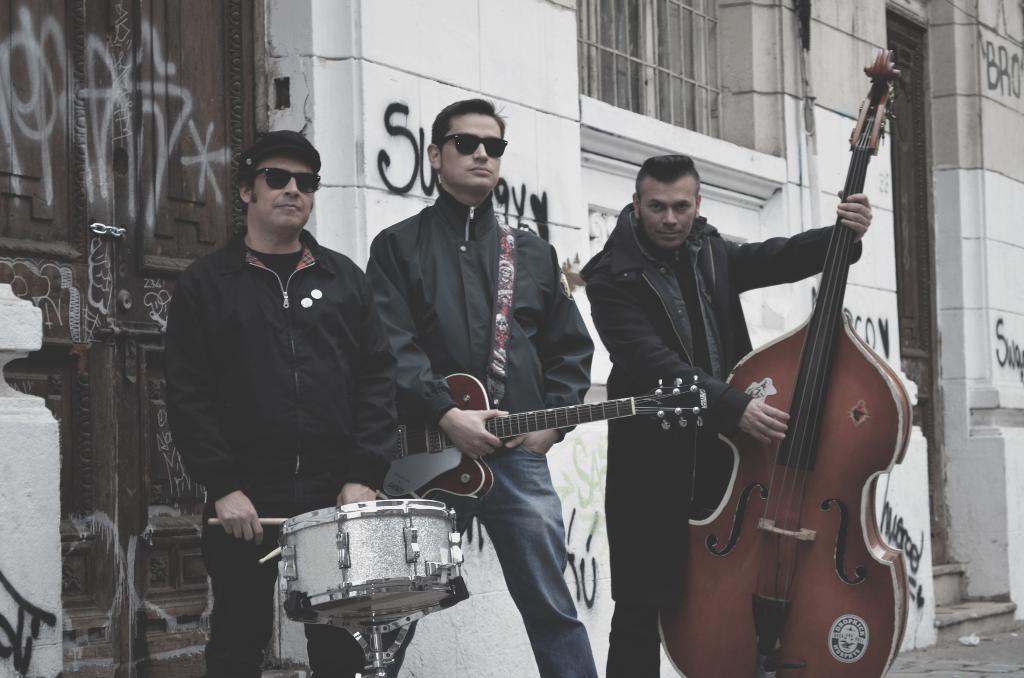In one or two sentences, can you explain what this image depicts? In this picture we can see three persons standing in the middle. On the right side these two persons are holding a guitar with their hands. And he has goggles. And he is playing drums. On the background we can see the wall and this is the door. 